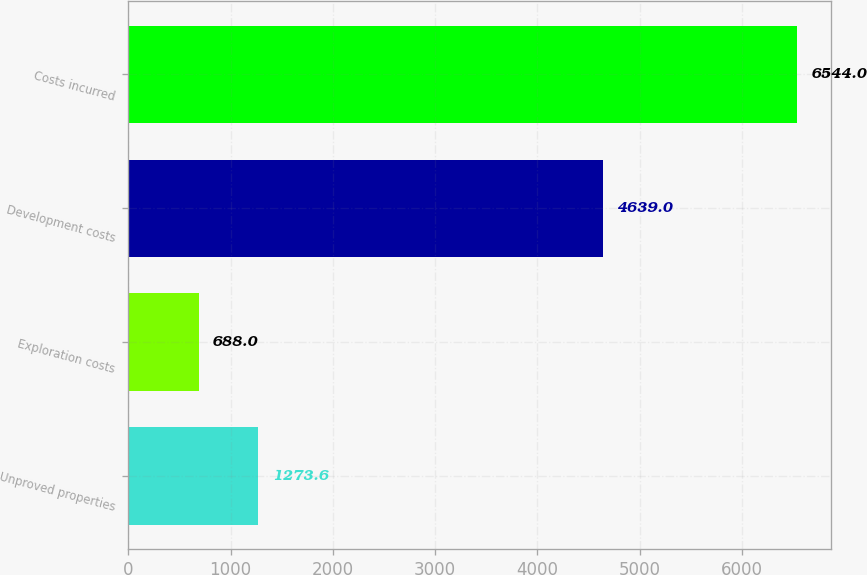<chart> <loc_0><loc_0><loc_500><loc_500><bar_chart><fcel>Unproved properties<fcel>Exploration costs<fcel>Development costs<fcel>Costs incurred<nl><fcel>1273.6<fcel>688<fcel>4639<fcel>6544<nl></chart> 